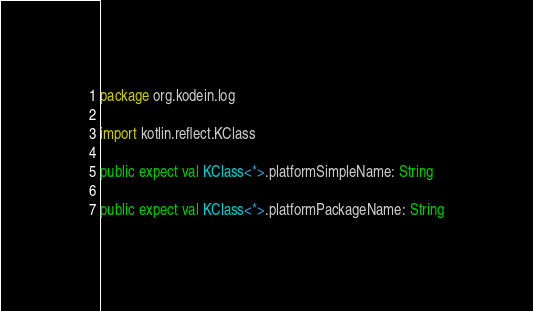<code> <loc_0><loc_0><loc_500><loc_500><_Kotlin_>package org.kodein.log

import kotlin.reflect.KClass

public expect val KClass<*>.platformSimpleName: String

public expect val KClass<*>.platformPackageName: String
</code> 